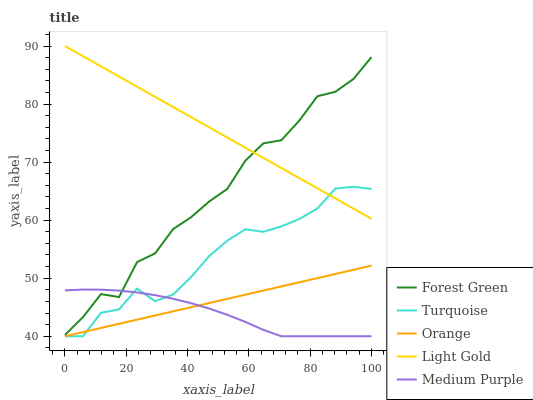Does Medium Purple have the minimum area under the curve?
Answer yes or no. Yes. Does Light Gold have the maximum area under the curve?
Answer yes or no. Yes. Does Forest Green have the minimum area under the curve?
Answer yes or no. No. Does Forest Green have the maximum area under the curve?
Answer yes or no. No. Is Orange the smoothest?
Answer yes or no. Yes. Is Forest Green the roughest?
Answer yes or no. Yes. Is Medium Purple the smoothest?
Answer yes or no. No. Is Medium Purple the roughest?
Answer yes or no. No. Does Orange have the lowest value?
Answer yes or no. Yes. Does Forest Green have the lowest value?
Answer yes or no. No. Does Light Gold have the highest value?
Answer yes or no. Yes. Does Forest Green have the highest value?
Answer yes or no. No. Is Turquoise less than Forest Green?
Answer yes or no. Yes. Is Light Gold greater than Orange?
Answer yes or no. Yes. Does Light Gold intersect Turquoise?
Answer yes or no. Yes. Is Light Gold less than Turquoise?
Answer yes or no. No. Is Light Gold greater than Turquoise?
Answer yes or no. No. Does Turquoise intersect Forest Green?
Answer yes or no. No. 